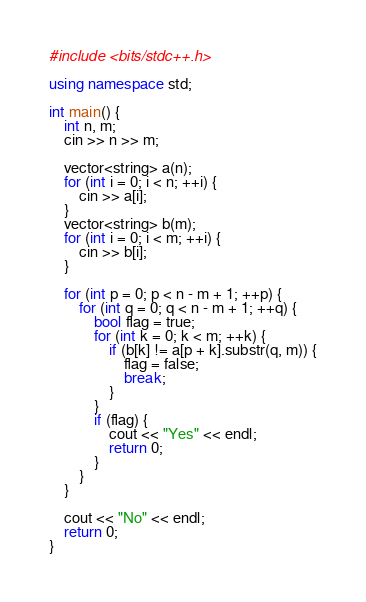Convert code to text. <code><loc_0><loc_0><loc_500><loc_500><_C++_>#include <bits/stdc++.h>

using namespace std;

int main() {
    int n, m;
    cin >> n >> m;

    vector<string> a(n);
    for (int i = 0; i < n; ++i) {
        cin >> a[i];
    }
    vector<string> b(m);
    for (int i = 0; i < m; ++i) {
        cin >> b[i];
    }

    for (int p = 0; p < n - m + 1; ++p) {
        for (int q = 0; q < n - m + 1; ++q) {
            bool flag = true;
            for (int k = 0; k < m; ++k) {
                if (b[k] != a[p + k].substr(q, m)) {
                    flag = false;
                    break;
                }
            }
            if (flag) {
                cout << "Yes" << endl;
                return 0;
            }
        }
    }

    cout << "No" << endl;
    return 0;
}
</code> 